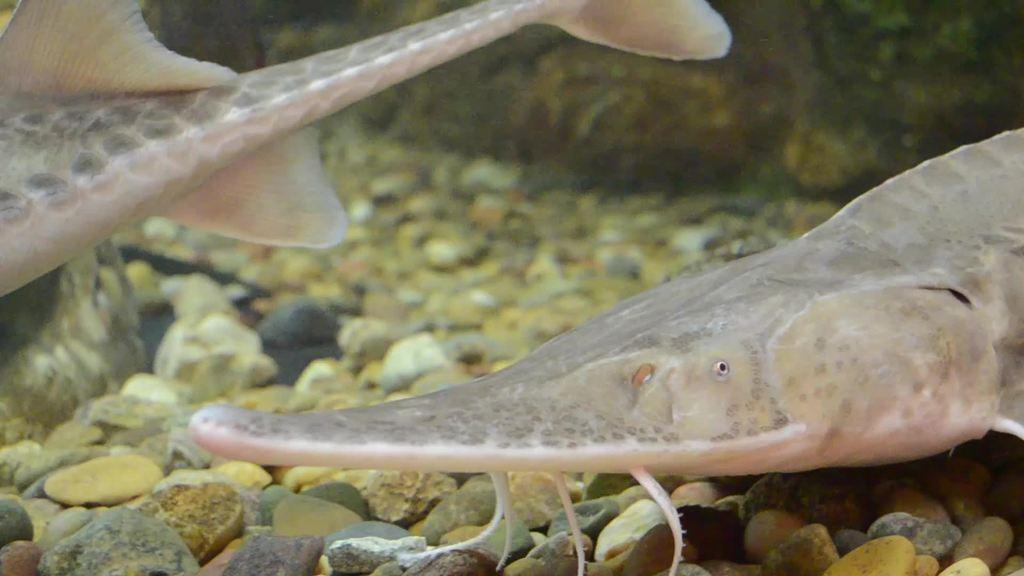How many fish can be seen in the image? There are two fish in the image. What are the fish doing in the image? The fish are swimming in the water. What can be seen in the background of the image? There are stones visible in the background of the image. What type of power source is used to move the fish in the image? There is no indication in the image that the fish are being moved by a power source; they are swimming naturally in the water. 